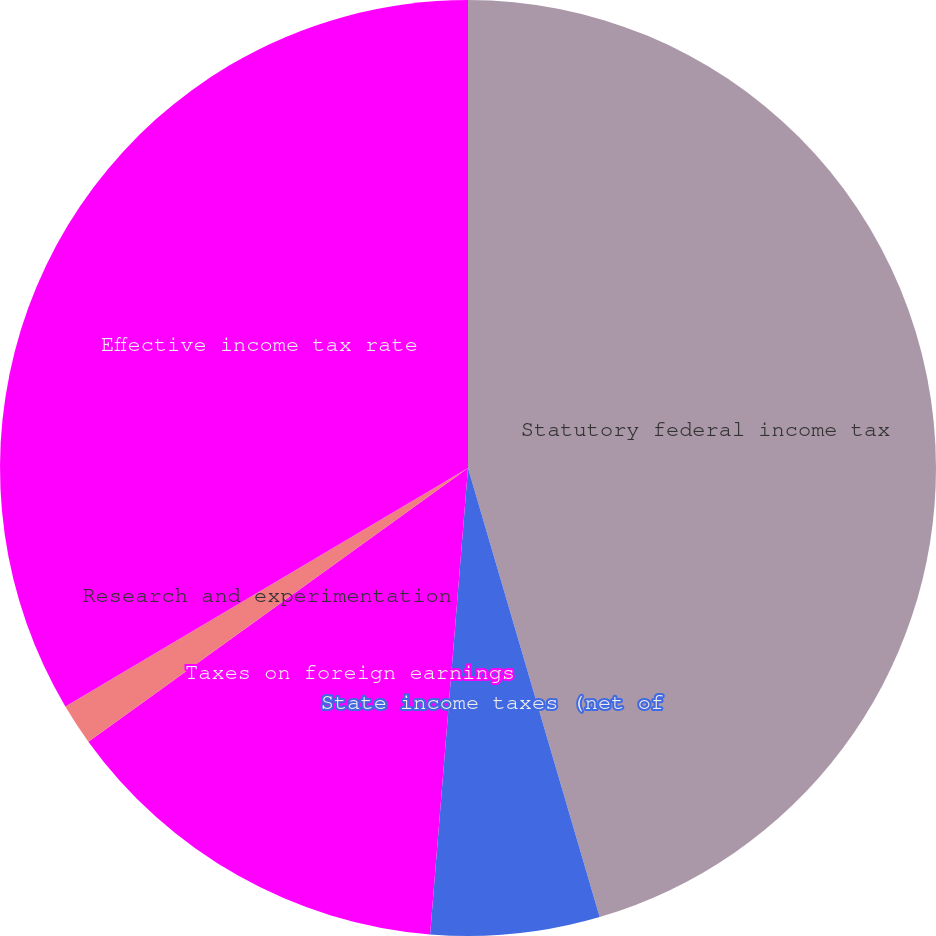Convert chart. <chart><loc_0><loc_0><loc_500><loc_500><pie_chart><fcel>Statutory federal income tax<fcel>State income taxes (net of<fcel>Taxes on foreign earnings<fcel>Research and experimentation<fcel>Effective income tax rate<nl><fcel>45.46%<fcel>5.83%<fcel>13.77%<fcel>1.43%<fcel>33.51%<nl></chart> 